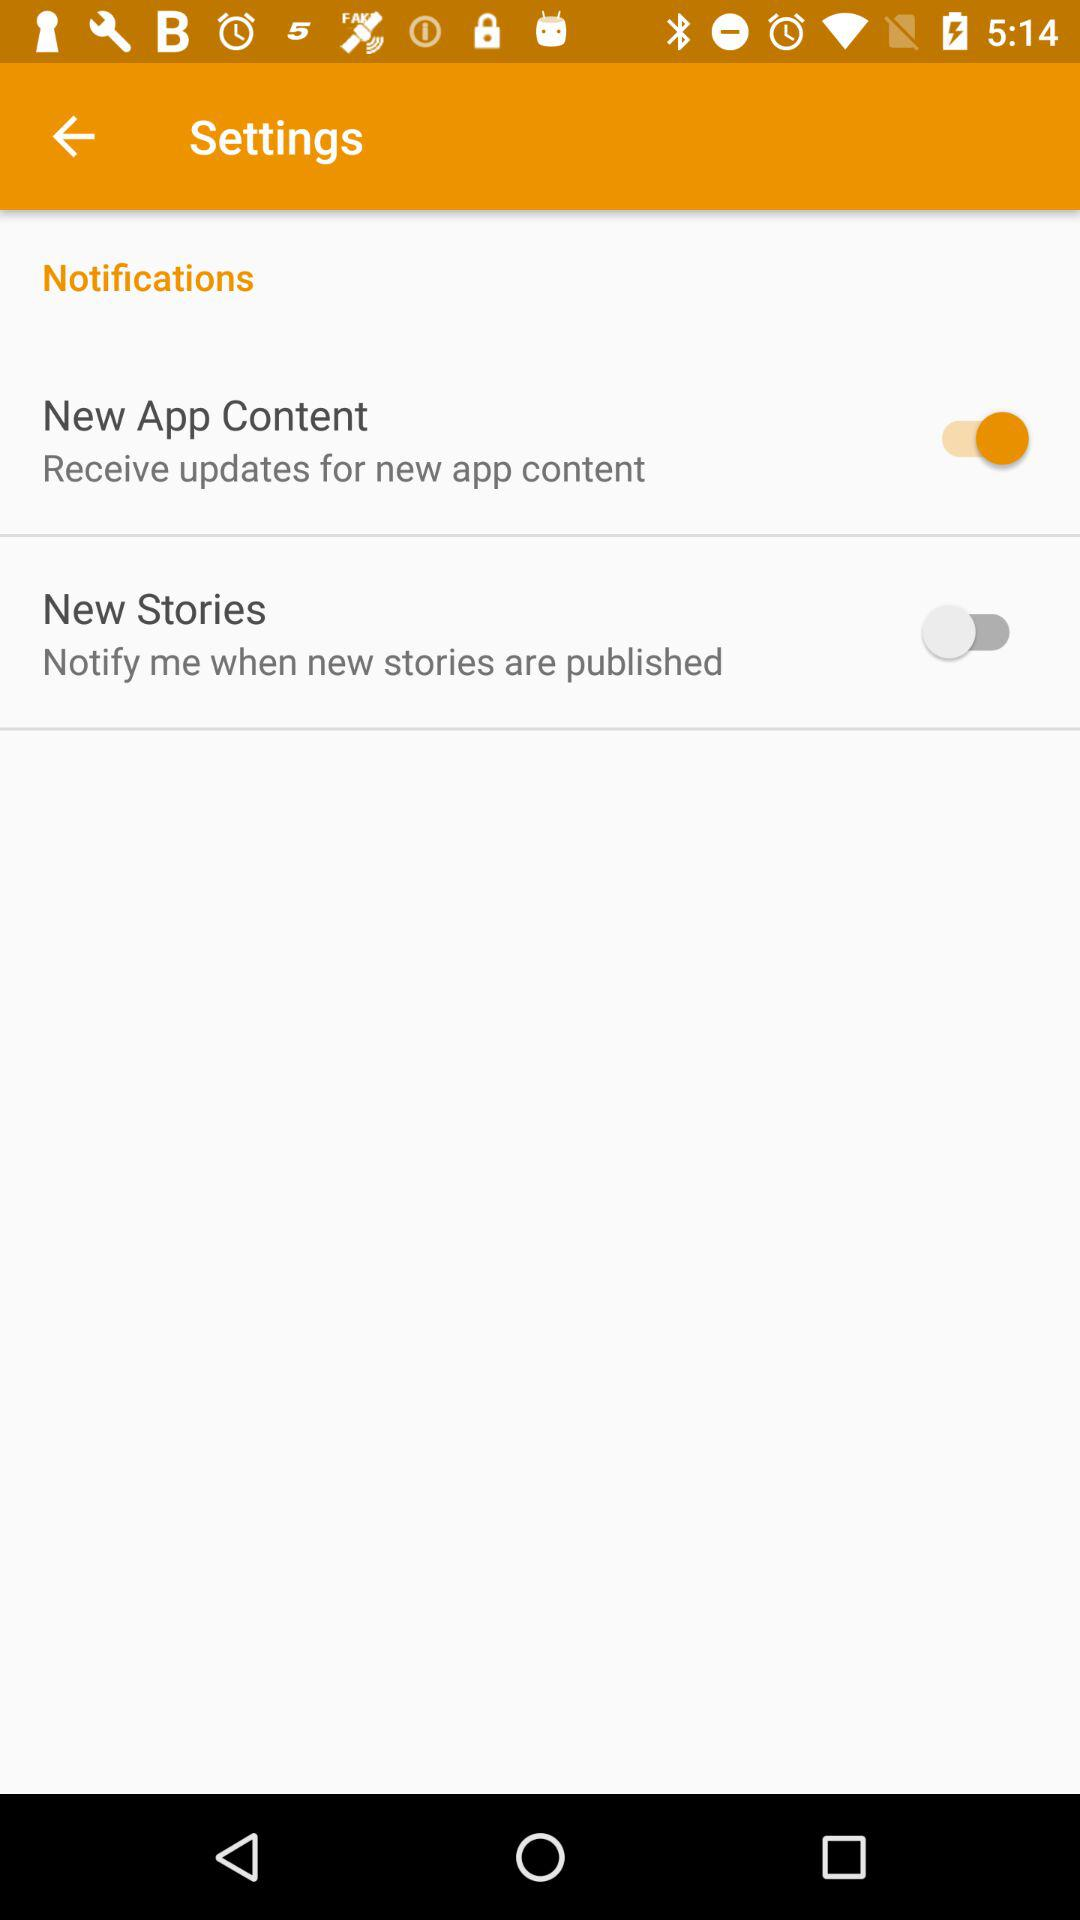When was the last new story published?
When the provided information is insufficient, respond with <no answer>. <no answer> 